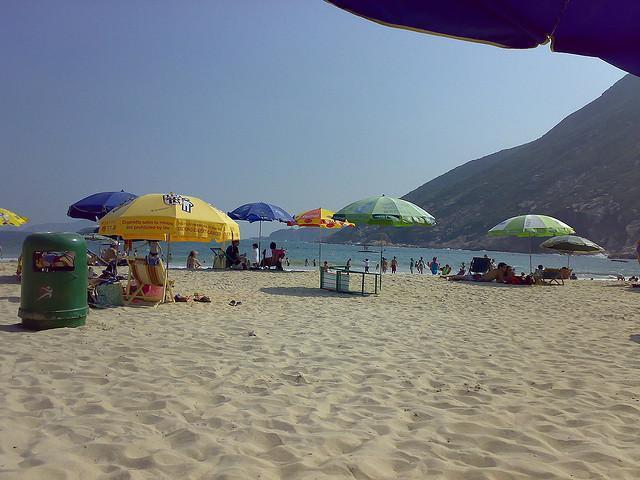How many umbrellas are in the picture?
Give a very brief answer. 8. How many yellow umbrellas?
Give a very brief answer. 3. How many yellow umbrellas are standing?
Give a very brief answer. 3. How many yellow umbrellas are there?
Give a very brief answer. 3. How many umbrellas are there?
Give a very brief answer. 2. How many clocks have red numbers?
Give a very brief answer. 0. 